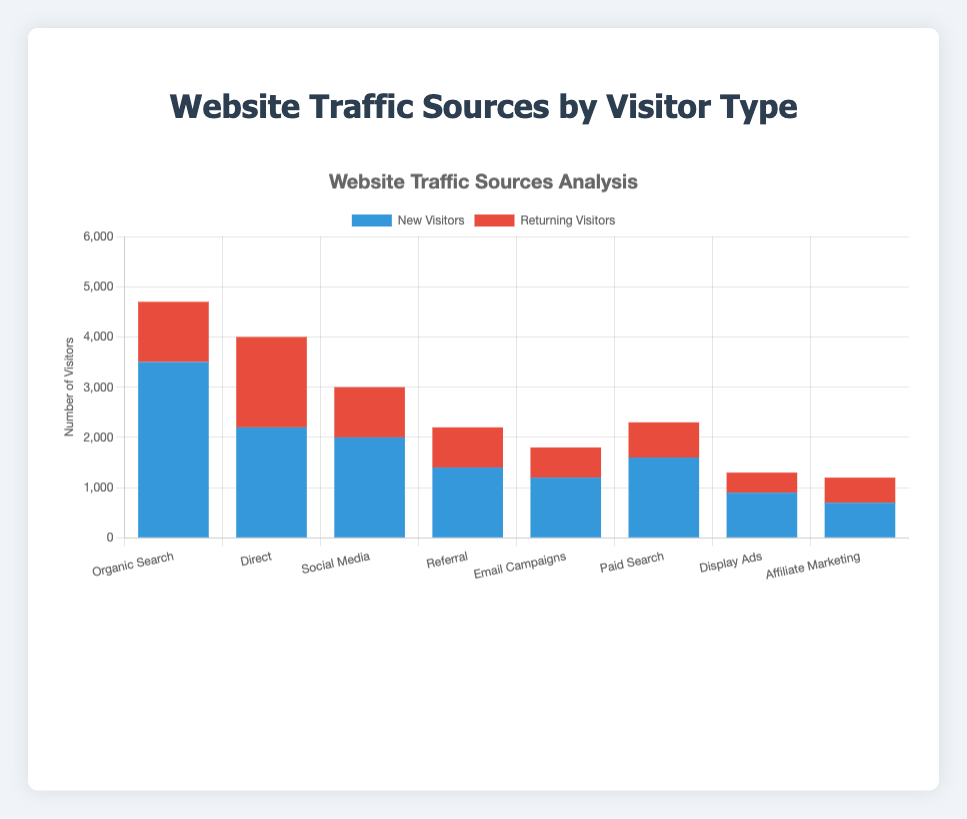what is the total number of visitors from Organic Search? Add the number of new visitors and returning visitors from Organic Search: 3500 (new) + 1200 (returning) = 4700
Answer: 4700 Which source has the highest number of new visitors? Look for the tallest blue bar representing new visitors. Organic Search has the highest new visitor count of 3500.
Answer: Organic Search How many more new visitors does Organic Search have compared to Direct traffic? Subtract the number of new visitors from Direct traffic from Organic Search. 3500 (Organic) - 2200 (Direct) = 1300
Answer: 1300 Which source has the least number of returning visitors? Look for the shortest red bar representing returning visitors. Display Ads has the least returning visitors with 400.
Answer: Display Ads What is the average number of new visitors across all sources? Sum the number of new visitors across all sources and divide by the number of sources. (3500 + 2200 + 2000 + 1400 + 1200 + 1600 + 900 + 700) / 8 = 13500 / 8 = 1687.5
Answer: 1687.5 Is the number of returning visitors from Social Media greater than that from Email Campaigns? Compare the heights of the red bars for Social Media and Email Campaigns. Social Media has 1000 returning visitors and Email Campaigns has 600, so yes, Social Media has more returning visitors.
Answer: Yes Which source has the highest total number of visitors (new and returning combined)? Add the new and returning visitors for each source and determine which has the highest total. Organic Search total = 3500 + 1200 = 4700, Direct total = 2200 + 1800 = 4000, ...(other sources calculated similarly)... The highest is Organic Search with 4700 total.
Answer: Organic Search What is the percentage of returning visitors for Paid Search? Calculate the percentage of returning visitors out of the total visitors for Paid Search. (700/2300) * 100 = 30.43%
Answer: 30.43% What is the difference in the number of new visitors between Social Media and Display Ads? Subtract the number of new visitors for Display Ads from Social Media. 2000 (Social Media) - 900 (Display Ads) = 1100
Answer: 1100 